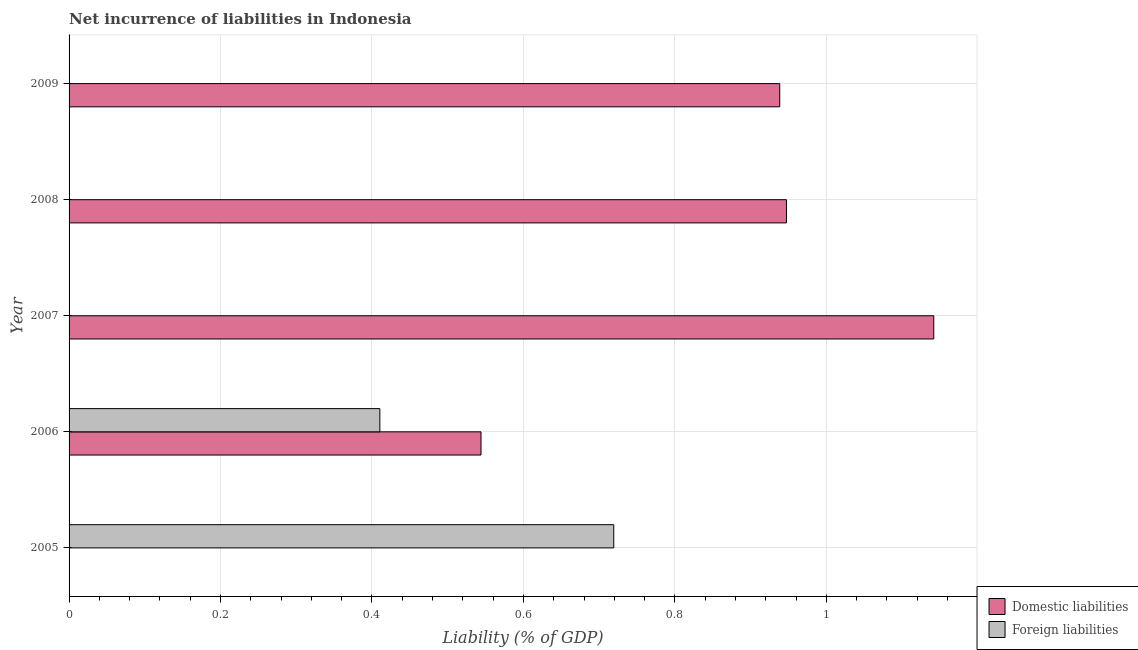Are the number of bars per tick equal to the number of legend labels?
Make the answer very short. No. How many bars are there on the 4th tick from the bottom?
Your response must be concise. 1. In how many cases, is the number of bars for a given year not equal to the number of legend labels?
Provide a short and direct response. 4. What is the incurrence of domestic liabilities in 2006?
Your answer should be very brief. 0.54. Across all years, what is the maximum incurrence of domestic liabilities?
Your response must be concise. 1.14. In which year was the incurrence of domestic liabilities maximum?
Provide a short and direct response. 2007. What is the total incurrence of domestic liabilities in the graph?
Offer a terse response. 3.57. What is the difference between the incurrence of domestic liabilities in 2006 and that in 2008?
Your answer should be very brief. -0.4. What is the difference between the incurrence of foreign liabilities in 2006 and the incurrence of domestic liabilities in 2009?
Your response must be concise. -0.53. What is the average incurrence of foreign liabilities per year?
Offer a terse response. 0.23. In the year 2006, what is the difference between the incurrence of domestic liabilities and incurrence of foreign liabilities?
Your answer should be very brief. 0.13. In how many years, is the incurrence of foreign liabilities greater than 0.32 %?
Make the answer very short. 2. Is the incurrence of domestic liabilities in 2007 less than that in 2008?
Offer a very short reply. No. What is the difference between the highest and the second highest incurrence of domestic liabilities?
Your answer should be compact. 0.2. What is the difference between the highest and the lowest incurrence of foreign liabilities?
Your answer should be very brief. 0.72. Is the sum of the incurrence of domestic liabilities in 2006 and 2008 greater than the maximum incurrence of foreign liabilities across all years?
Give a very brief answer. Yes. How many years are there in the graph?
Provide a succinct answer. 5. How are the legend labels stacked?
Ensure brevity in your answer.  Vertical. What is the title of the graph?
Your answer should be compact. Net incurrence of liabilities in Indonesia. What is the label or title of the X-axis?
Provide a short and direct response. Liability (% of GDP). What is the Liability (% of GDP) of Domestic liabilities in 2005?
Offer a terse response. 0. What is the Liability (% of GDP) in Foreign liabilities in 2005?
Provide a short and direct response. 0.72. What is the Liability (% of GDP) in Domestic liabilities in 2006?
Your response must be concise. 0.54. What is the Liability (% of GDP) in Foreign liabilities in 2006?
Your answer should be compact. 0.41. What is the Liability (% of GDP) of Domestic liabilities in 2007?
Your response must be concise. 1.14. What is the Liability (% of GDP) of Domestic liabilities in 2008?
Give a very brief answer. 0.95. What is the Liability (% of GDP) of Domestic liabilities in 2009?
Your answer should be compact. 0.94. What is the Liability (% of GDP) of Foreign liabilities in 2009?
Give a very brief answer. 0. Across all years, what is the maximum Liability (% of GDP) in Domestic liabilities?
Ensure brevity in your answer.  1.14. Across all years, what is the maximum Liability (% of GDP) in Foreign liabilities?
Make the answer very short. 0.72. Across all years, what is the minimum Liability (% of GDP) of Foreign liabilities?
Ensure brevity in your answer.  0. What is the total Liability (% of GDP) of Domestic liabilities in the graph?
Offer a very short reply. 3.57. What is the total Liability (% of GDP) in Foreign liabilities in the graph?
Make the answer very short. 1.13. What is the difference between the Liability (% of GDP) of Foreign liabilities in 2005 and that in 2006?
Offer a very short reply. 0.31. What is the difference between the Liability (% of GDP) in Domestic liabilities in 2006 and that in 2007?
Make the answer very short. -0.6. What is the difference between the Liability (% of GDP) in Domestic liabilities in 2006 and that in 2008?
Keep it short and to the point. -0.4. What is the difference between the Liability (% of GDP) of Domestic liabilities in 2006 and that in 2009?
Offer a terse response. -0.39. What is the difference between the Liability (% of GDP) in Domestic liabilities in 2007 and that in 2008?
Offer a terse response. 0.19. What is the difference between the Liability (% of GDP) of Domestic liabilities in 2007 and that in 2009?
Your response must be concise. 0.2. What is the difference between the Liability (% of GDP) in Domestic liabilities in 2008 and that in 2009?
Offer a very short reply. 0.01. What is the average Liability (% of GDP) in Domestic liabilities per year?
Offer a terse response. 0.71. What is the average Liability (% of GDP) in Foreign liabilities per year?
Provide a succinct answer. 0.23. In the year 2006, what is the difference between the Liability (% of GDP) in Domestic liabilities and Liability (% of GDP) in Foreign liabilities?
Provide a succinct answer. 0.13. What is the ratio of the Liability (% of GDP) of Foreign liabilities in 2005 to that in 2006?
Make the answer very short. 1.75. What is the ratio of the Liability (% of GDP) in Domestic liabilities in 2006 to that in 2007?
Your response must be concise. 0.48. What is the ratio of the Liability (% of GDP) of Domestic liabilities in 2006 to that in 2008?
Your answer should be compact. 0.57. What is the ratio of the Liability (% of GDP) in Domestic liabilities in 2006 to that in 2009?
Make the answer very short. 0.58. What is the ratio of the Liability (% of GDP) in Domestic liabilities in 2007 to that in 2008?
Keep it short and to the point. 1.21. What is the ratio of the Liability (% of GDP) in Domestic liabilities in 2007 to that in 2009?
Your answer should be very brief. 1.22. What is the ratio of the Liability (% of GDP) of Domestic liabilities in 2008 to that in 2009?
Ensure brevity in your answer.  1.01. What is the difference between the highest and the second highest Liability (% of GDP) of Domestic liabilities?
Make the answer very short. 0.19. What is the difference between the highest and the lowest Liability (% of GDP) in Domestic liabilities?
Keep it short and to the point. 1.14. What is the difference between the highest and the lowest Liability (% of GDP) in Foreign liabilities?
Keep it short and to the point. 0.72. 